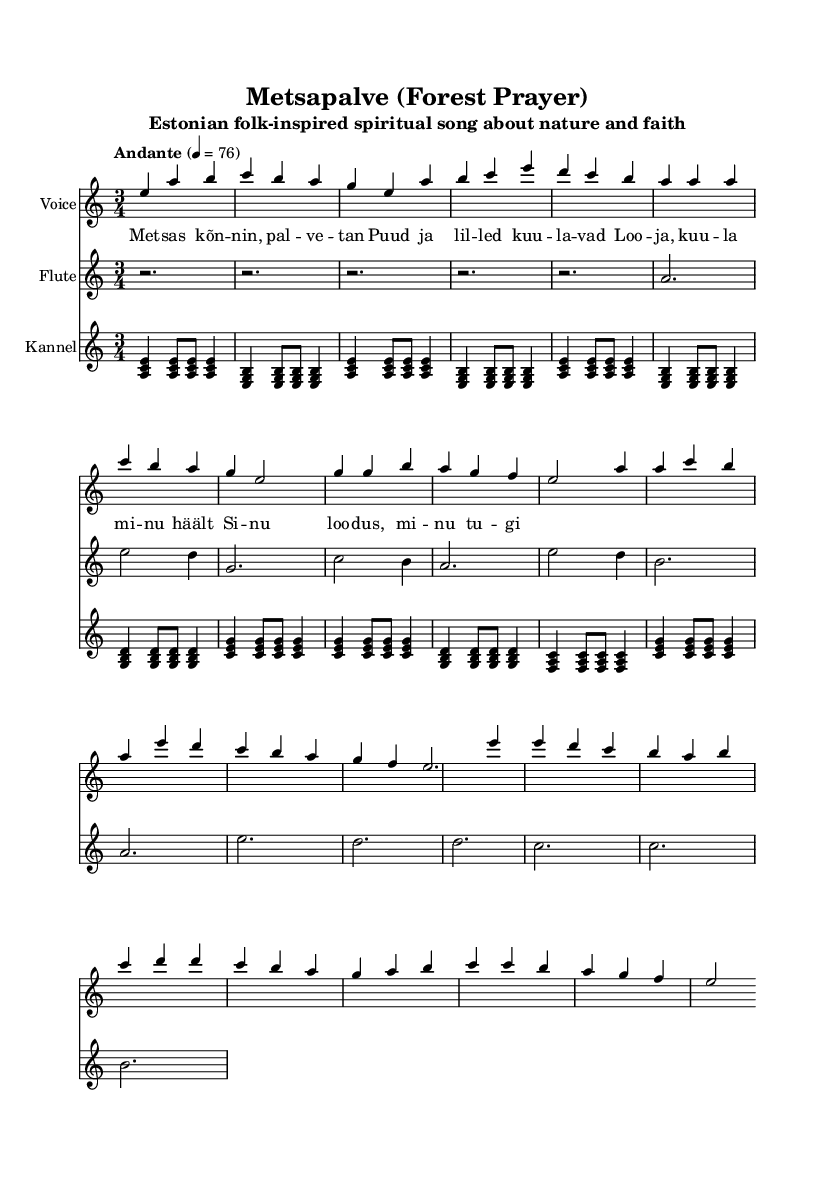What is the key signature of this music? The key signature is indicated at the beginning of the staff and shows an 'A', which signifies that the key signature for A minor is used, having no sharps or flats.
Answer: A minor What is the time signature of this music? The time signature is also shown at the beginning of the score, represented by the fraction '3/4', indicating that there are three beats per measure and the quarter note gets one beat.
Answer: 3/4 What is the tempo marking of this piece? The tempo marking is given in Italian as "Andante" which implies a moderate walking pace, alongside a metronome marking of 76 quarter notes per minute.
Answer: Andante What instruments are featured in this sheet music? The sheet music explicitly identifies three instruments: Voice, Flute, and Kannel, each represented on its own staff.
Answer: Voice, Flute, Kannel How many measures are in the verse section? By counting the measures in the "Verse" section specifically indicated in the voice part, there are a total of 8 measures present.
Answer: 8 What is the lyric theme of the song? The lyrics discussed in the music are indicated in the lyrics block, consisting of spiritual themes focusing on nature and the creator, with a specific mention of calling to the Creator.
Answer: Spirituality and nature What does the chorus repetition indicate about the song's structure? The repetition of the lyrics in the chorus section suggests a common structure in folk-inspired spiritual songs emphasizing key messages or themes, which in this case relate to praising the Creator and seeking a connection with nature.
Answer: Repetition emphasizes key themes 